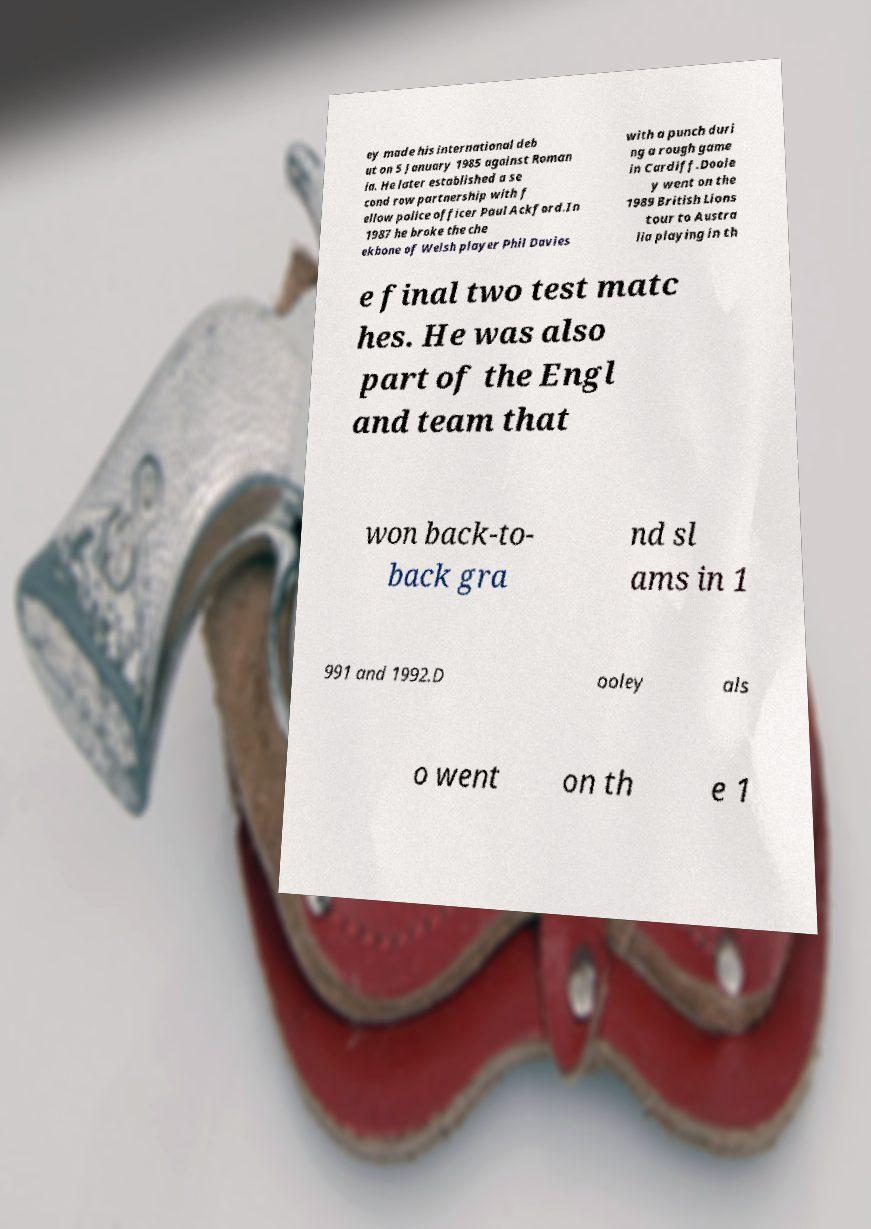Could you assist in decoding the text presented in this image and type it out clearly? ey made his international deb ut on 5 January 1985 against Roman ia. He later established a se cond row partnership with f ellow police officer Paul Ackford.In 1987 he broke the che ekbone of Welsh player Phil Davies with a punch duri ng a rough game in Cardiff.Doole y went on the 1989 British Lions tour to Austra lia playing in th e final two test matc hes. He was also part of the Engl and team that won back-to- back gra nd sl ams in 1 991 and 1992.D ooley als o went on th e 1 